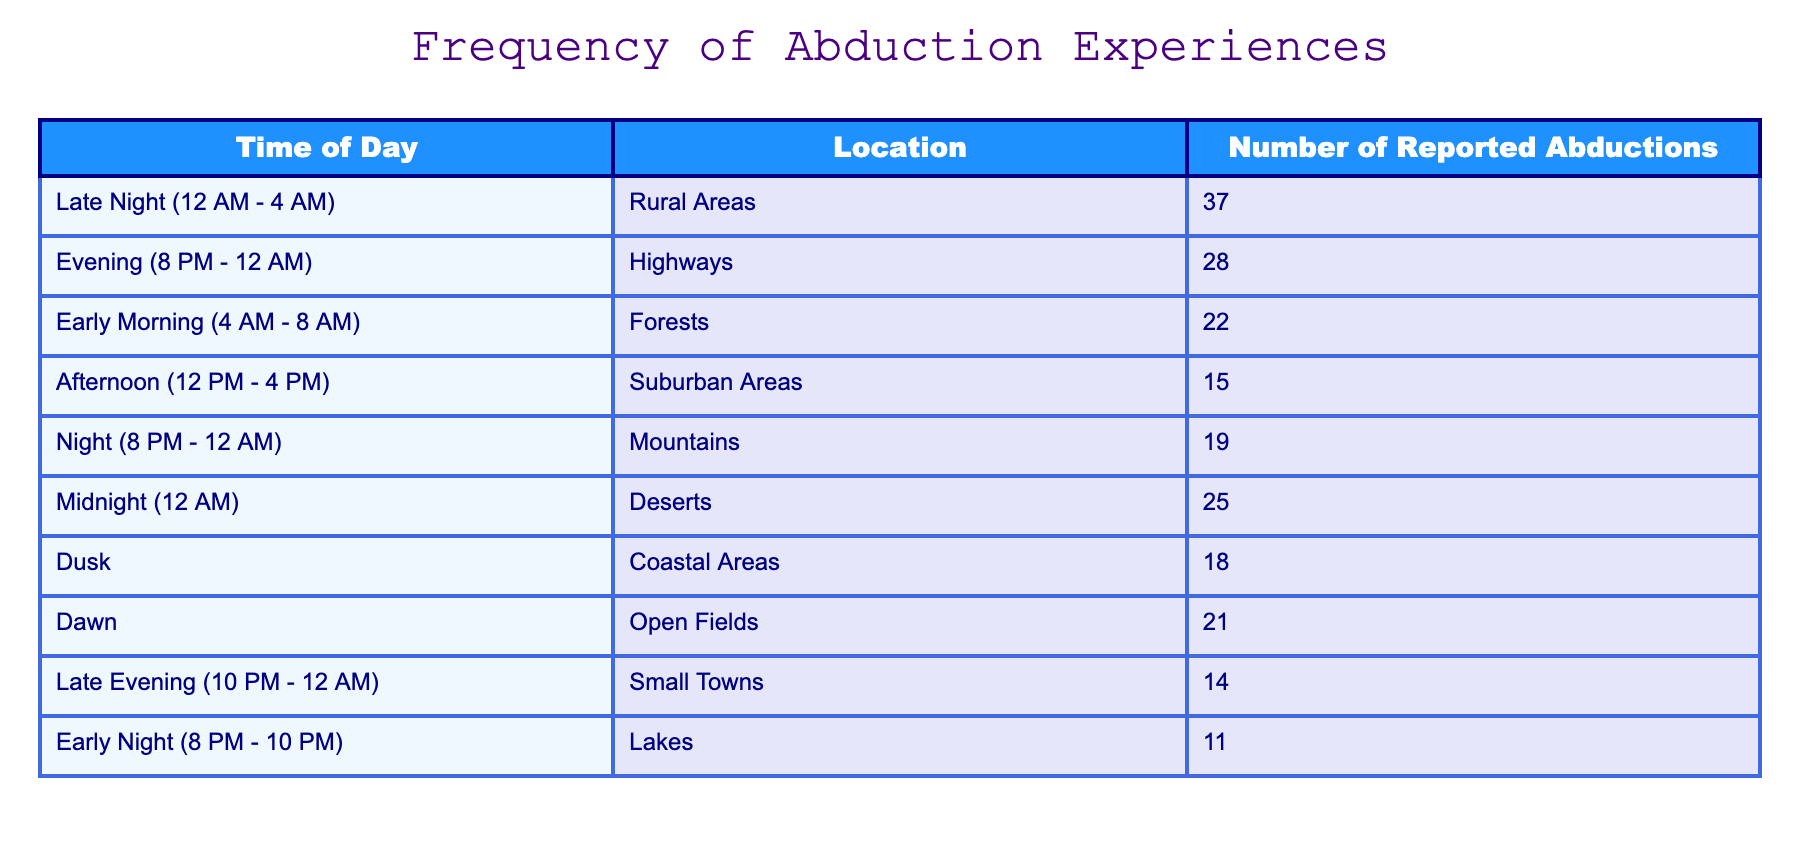What is the highest number of reported abductions? The highest number of reported abductions is found in the "Late Night (12 AM - 4 AM)" row, which has 37 abduction reports.
Answer: 37 During which time of day do the most abductions occur in Rural Areas? The "Late Night (12 AM - 4 AM)" category has the highest frequency of reported abductions (37) specifically in Rural Areas.
Answer: Late Night (12 AM - 4 AM) How many total reported abductions occurred in the Evening and Late Evening combined? We sum the "Evening (8 PM - 12 AM)" (28 abductions) and "Late Evening (10 PM - 12 AM)" (14 abductions) which gives us 28 + 14 = 42 total reported abductions in these two time slots.
Answer: 42 Are there more reported abductions at Midnight than in the Afternoon? The Midnight (12 AM) reports total 25, while the Afternoon (12 PM - 4 PM) reports total 15. Therefore, there are indeed more reported abductions at Midnight than in the Afternoon.
Answer: Yes What is the average number of reported abductions during Night and Late Night? For Night (8 PM - 12 AM) the count is 19, and for Late Night (12 AM - 4 AM) it is 37. Adding these together gives 19 + 37 = 56, then dividing by 2 for the average yields 56/2 = 28.
Answer: 28 Which location had the least reported abductions? The row for "Early Night (8 PM - 10 PM)" shows the least number of reported abductions at 11.
Answer: 11 What is the difference in reported abductions between the Coastal Areas and Mountains? Coastal Areas report 18 abductions and Mountains report 19. The difference between them is 19 - 18 = 1.
Answer: 1 Is the number of reported abductions greater in Rural Areas compared to Coastal Areas? Rural Areas show 37 reported abductions, while Coastal Areas have 18, indicating that Rural Areas indeed have more.
Answer: Yes How many reported abductions occurred in the Forestation vs. the Deserts? The Forestation reports 22 and the Deserts report 25, so the difference is 25 - 22 = 3, so there are 3 more abductions in Deserts than in the Forestation.
Answer: 3 